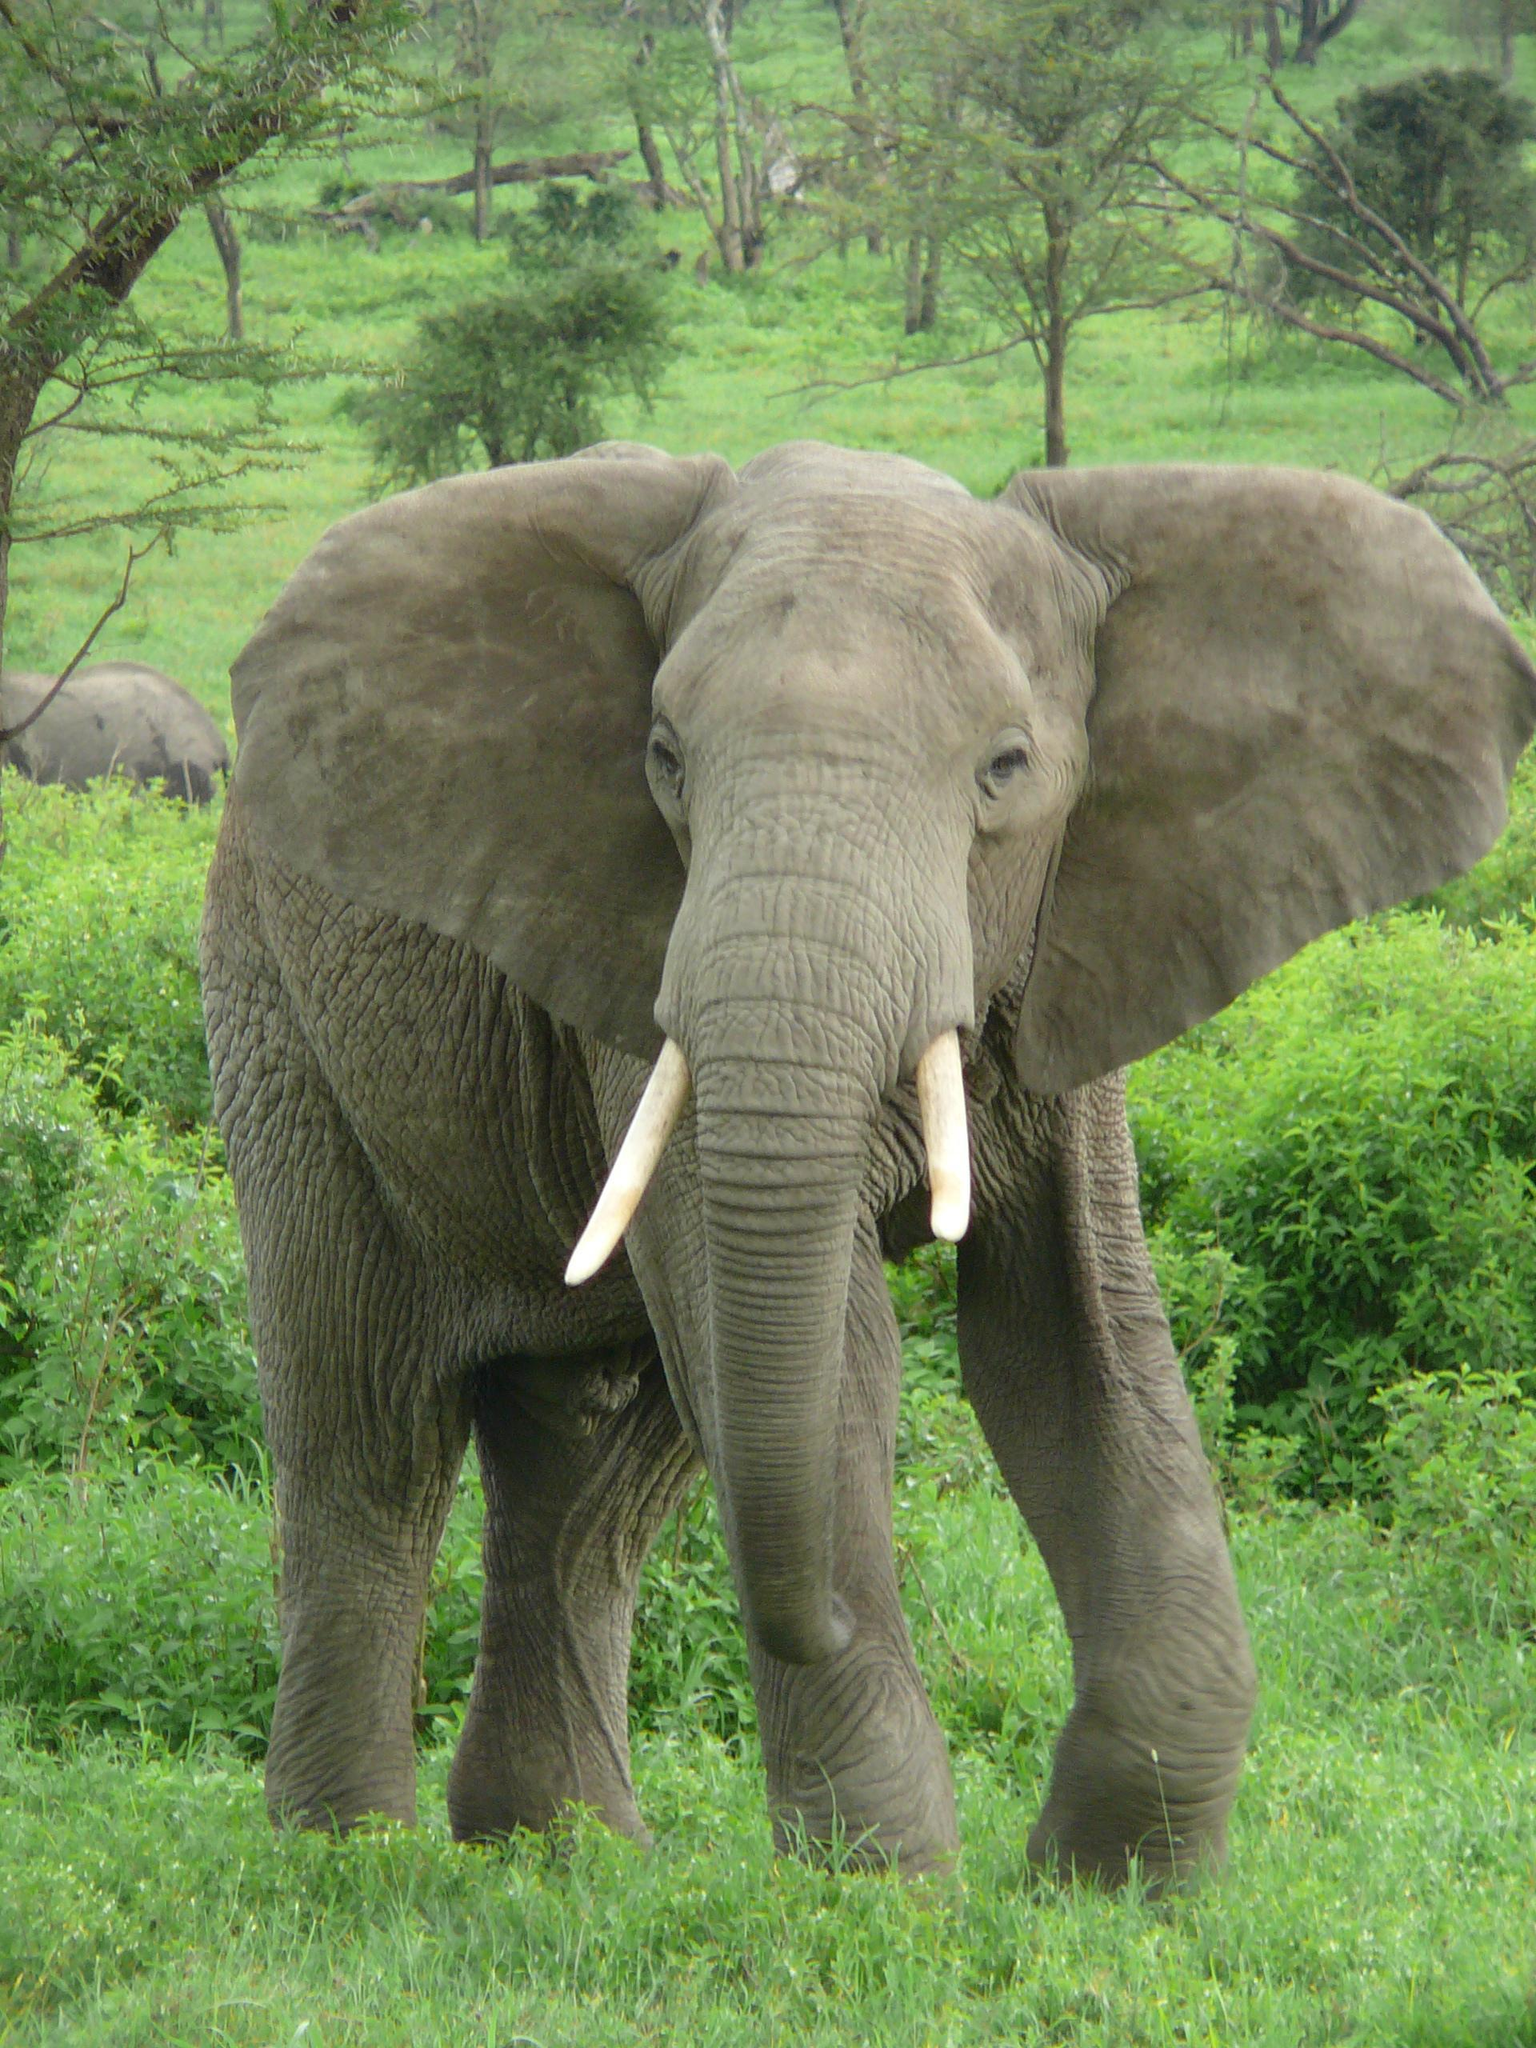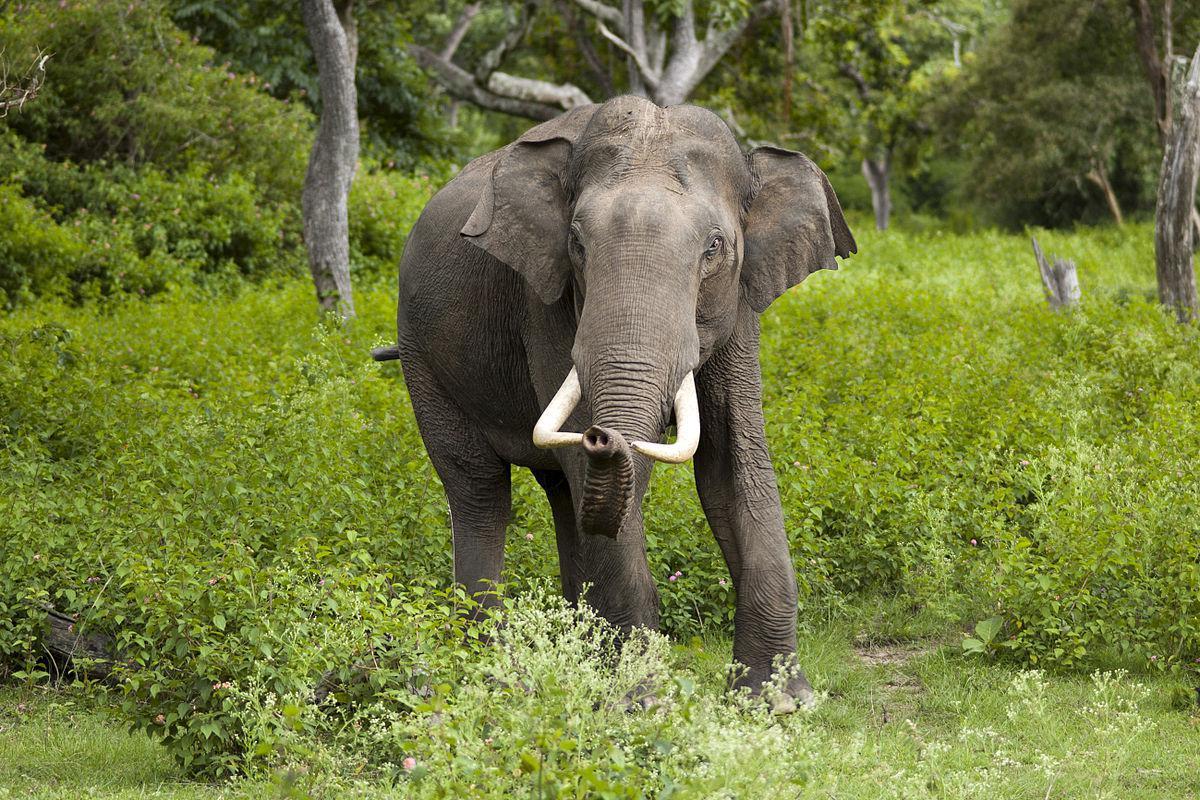The first image is the image on the left, the second image is the image on the right. Examine the images to the left and right. Is the description "In one image, and elephant with tusks has its ears fanned out their full width." accurate? Answer yes or no. Yes. 